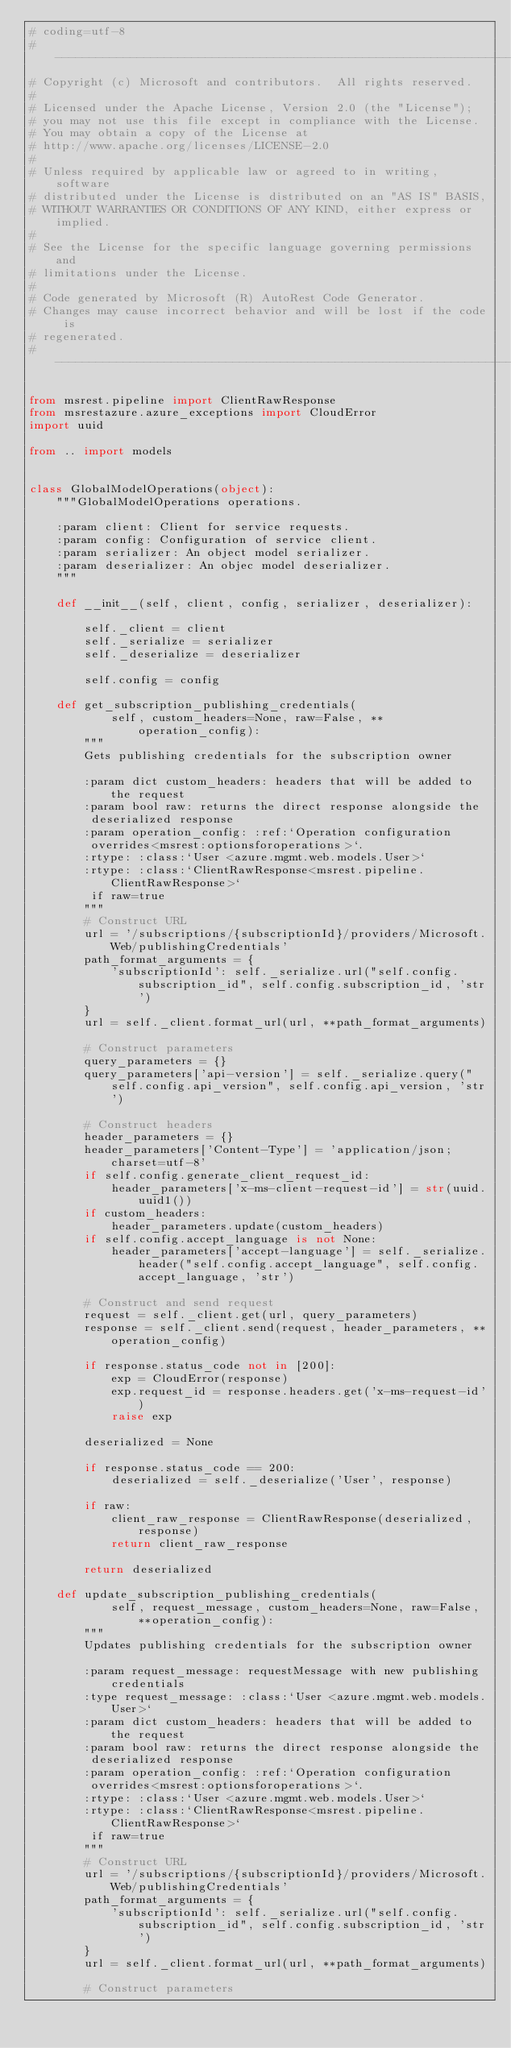Convert code to text. <code><loc_0><loc_0><loc_500><loc_500><_Python_># coding=utf-8
# --------------------------------------------------------------------------
# Copyright (c) Microsoft and contributors.  All rights reserved.
#
# Licensed under the Apache License, Version 2.0 (the "License");
# you may not use this file except in compliance with the License.
# You may obtain a copy of the License at
# http://www.apache.org/licenses/LICENSE-2.0
#
# Unless required by applicable law or agreed to in writing, software
# distributed under the License is distributed on an "AS IS" BASIS,
# WITHOUT WARRANTIES OR CONDITIONS OF ANY KIND, either express or implied.
#
# See the License for the specific language governing permissions and
# limitations under the License.
#
# Code generated by Microsoft (R) AutoRest Code Generator.
# Changes may cause incorrect behavior and will be lost if the code is
# regenerated.
# --------------------------------------------------------------------------

from msrest.pipeline import ClientRawResponse
from msrestazure.azure_exceptions import CloudError
import uuid

from .. import models


class GlobalModelOperations(object):
    """GlobalModelOperations operations.

    :param client: Client for service requests.
    :param config: Configuration of service client.
    :param serializer: An object model serializer.
    :param deserializer: An objec model deserializer.
    """

    def __init__(self, client, config, serializer, deserializer):

        self._client = client
        self._serialize = serializer
        self._deserialize = deserializer

        self.config = config

    def get_subscription_publishing_credentials(
            self, custom_headers=None, raw=False, **operation_config):
        """
        Gets publishing credentials for the subscription owner

        :param dict custom_headers: headers that will be added to the request
        :param bool raw: returns the direct response alongside the
         deserialized response
        :param operation_config: :ref:`Operation configuration
         overrides<msrest:optionsforoperations>`.
        :rtype: :class:`User <azure.mgmt.web.models.User>`
        :rtype: :class:`ClientRawResponse<msrest.pipeline.ClientRawResponse>`
         if raw=true
        """
        # Construct URL
        url = '/subscriptions/{subscriptionId}/providers/Microsoft.Web/publishingCredentials'
        path_format_arguments = {
            'subscriptionId': self._serialize.url("self.config.subscription_id", self.config.subscription_id, 'str')
        }
        url = self._client.format_url(url, **path_format_arguments)

        # Construct parameters
        query_parameters = {}
        query_parameters['api-version'] = self._serialize.query("self.config.api_version", self.config.api_version, 'str')

        # Construct headers
        header_parameters = {}
        header_parameters['Content-Type'] = 'application/json; charset=utf-8'
        if self.config.generate_client_request_id:
            header_parameters['x-ms-client-request-id'] = str(uuid.uuid1())
        if custom_headers:
            header_parameters.update(custom_headers)
        if self.config.accept_language is not None:
            header_parameters['accept-language'] = self._serialize.header("self.config.accept_language", self.config.accept_language, 'str')

        # Construct and send request
        request = self._client.get(url, query_parameters)
        response = self._client.send(request, header_parameters, **operation_config)

        if response.status_code not in [200]:
            exp = CloudError(response)
            exp.request_id = response.headers.get('x-ms-request-id')
            raise exp

        deserialized = None

        if response.status_code == 200:
            deserialized = self._deserialize('User', response)

        if raw:
            client_raw_response = ClientRawResponse(deserialized, response)
            return client_raw_response

        return deserialized

    def update_subscription_publishing_credentials(
            self, request_message, custom_headers=None, raw=False, **operation_config):
        """
        Updates publishing credentials for the subscription owner

        :param request_message: requestMessage with new publishing credentials
        :type request_message: :class:`User <azure.mgmt.web.models.User>`
        :param dict custom_headers: headers that will be added to the request
        :param bool raw: returns the direct response alongside the
         deserialized response
        :param operation_config: :ref:`Operation configuration
         overrides<msrest:optionsforoperations>`.
        :rtype: :class:`User <azure.mgmt.web.models.User>`
        :rtype: :class:`ClientRawResponse<msrest.pipeline.ClientRawResponse>`
         if raw=true
        """
        # Construct URL
        url = '/subscriptions/{subscriptionId}/providers/Microsoft.Web/publishingCredentials'
        path_format_arguments = {
            'subscriptionId': self._serialize.url("self.config.subscription_id", self.config.subscription_id, 'str')
        }
        url = self._client.format_url(url, **path_format_arguments)

        # Construct parameters</code> 